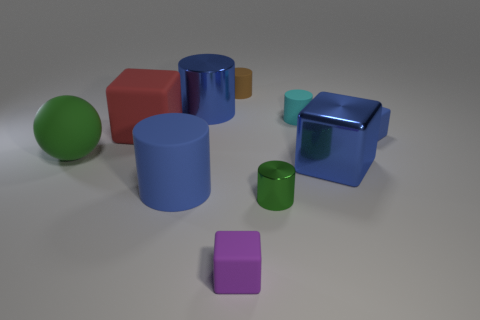Is the number of tiny matte cubes behind the rubber sphere greater than the number of tiny green rubber things? Yes, there appears to be only one tiny green rubber object, which is less than the number of matte cubes behind the rubber sphere. 